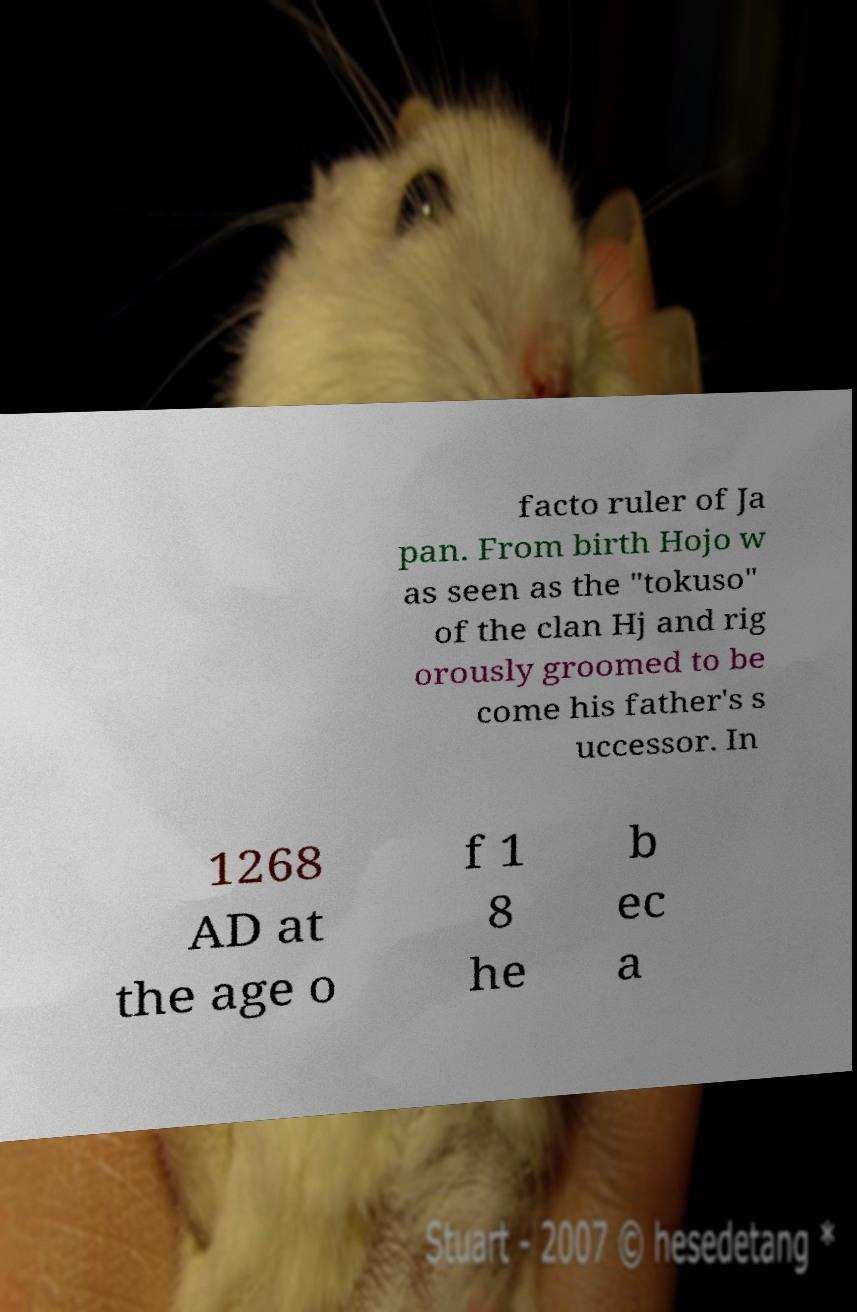For documentation purposes, I need the text within this image transcribed. Could you provide that? facto ruler of Ja pan. From birth Hojo w as seen as the "tokuso" of the clan Hj and rig orously groomed to be come his father's s uccessor. In 1268 AD at the age o f 1 8 he b ec a 